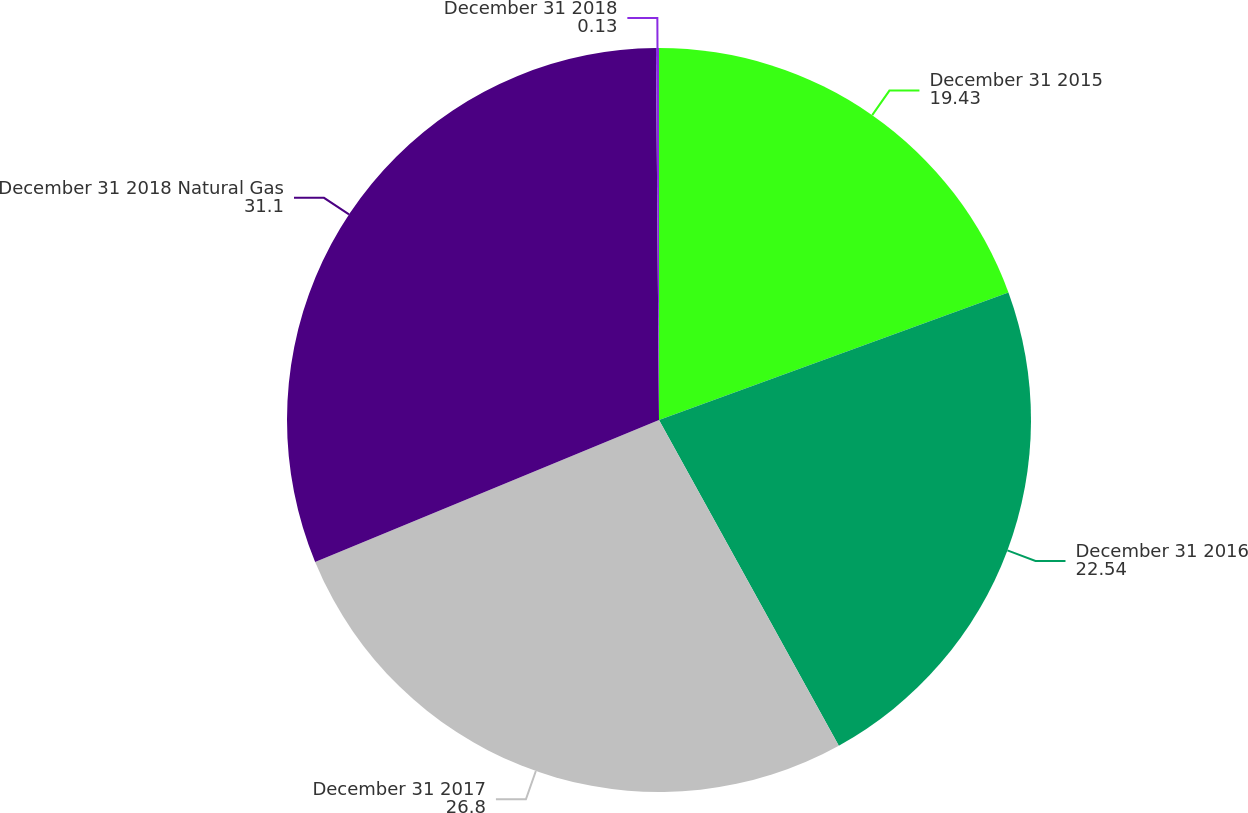Convert chart to OTSL. <chart><loc_0><loc_0><loc_500><loc_500><pie_chart><fcel>December 31 2015<fcel>December 31 2016<fcel>December 31 2017<fcel>December 31 2018 Natural Gas<fcel>December 31 2018<nl><fcel>19.43%<fcel>22.54%<fcel>26.8%<fcel>31.1%<fcel>0.13%<nl></chart> 